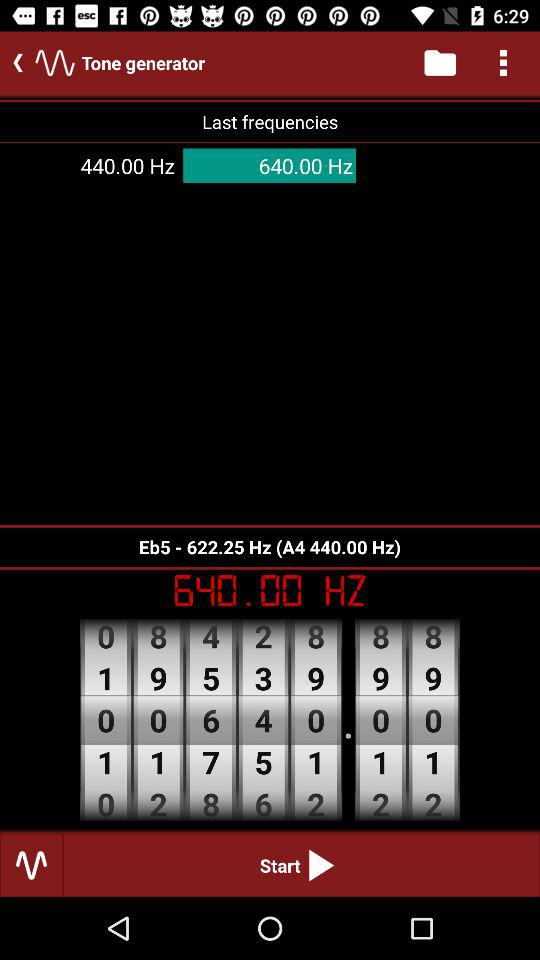What is the last frequency? The last two frequencies are 440.00 Hz and 640.00 Hz. 